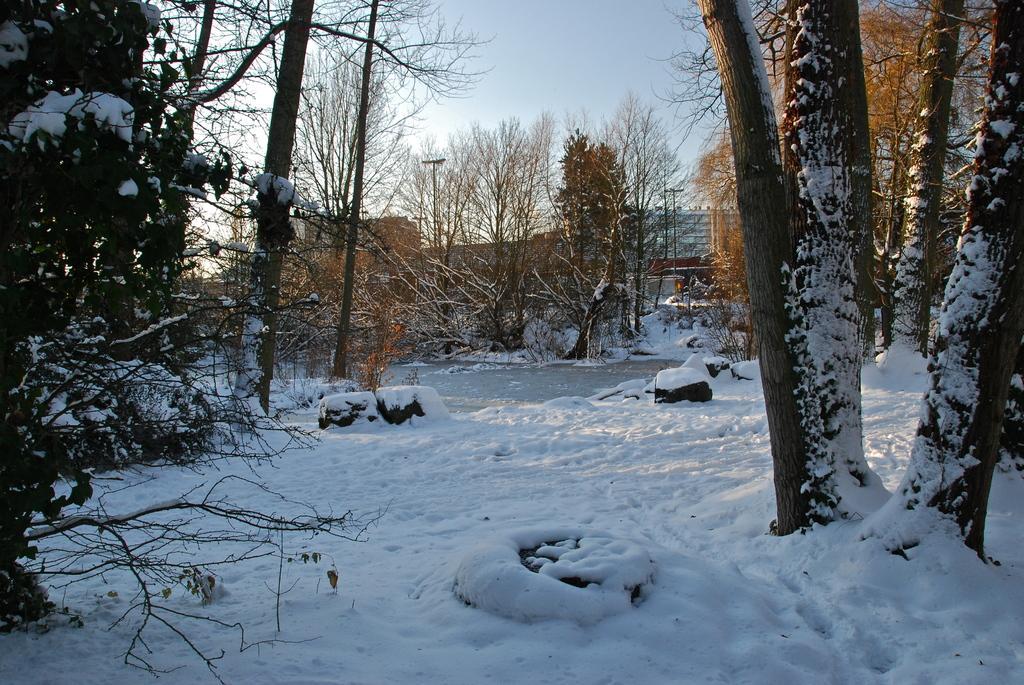In one or two sentences, can you explain what this image depicts? In this image there is snow at the bottom. There are trees on either side of the image. In the background there is a building at the last. The trees are covered with the snow. 